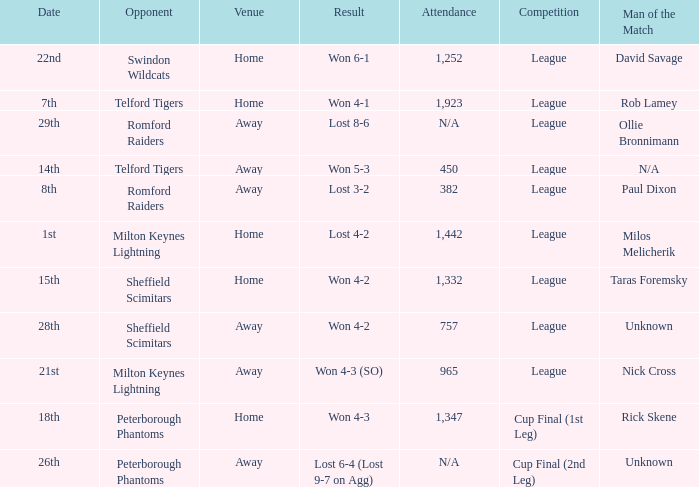On what date was the venue Away and the result was lost 6-4 (lost 9-7 on agg)? 26th. Parse the table in full. {'header': ['Date', 'Opponent', 'Venue', 'Result', 'Attendance', 'Competition', 'Man of the Match'], 'rows': [['22nd', 'Swindon Wildcats', 'Home', 'Won 6-1', '1,252', 'League', 'David Savage'], ['7th', 'Telford Tigers', 'Home', 'Won 4-1', '1,923', 'League', 'Rob Lamey'], ['29th', 'Romford Raiders', 'Away', 'Lost 8-6', 'N/A', 'League', 'Ollie Bronnimann'], ['14th', 'Telford Tigers', 'Away', 'Won 5-3', '450', 'League', 'N/A'], ['8th', 'Romford Raiders', 'Away', 'Lost 3-2', '382', 'League', 'Paul Dixon'], ['1st', 'Milton Keynes Lightning', 'Home', 'Lost 4-2', '1,442', 'League', 'Milos Melicherik'], ['15th', 'Sheffield Scimitars', 'Home', 'Won 4-2', '1,332', 'League', 'Taras Foremsky'], ['28th', 'Sheffield Scimitars', 'Away', 'Won 4-2', '757', 'League', 'Unknown'], ['21st', 'Milton Keynes Lightning', 'Away', 'Won 4-3 (SO)', '965', 'League', 'Nick Cross'], ['18th', 'Peterborough Phantoms', 'Home', 'Won 4-3', '1,347', 'Cup Final (1st Leg)', 'Rick Skene'], ['26th', 'Peterborough Phantoms', 'Away', 'Lost 6-4 (Lost 9-7 on Agg)', 'N/A', 'Cup Final (2nd Leg)', 'Unknown']]} 